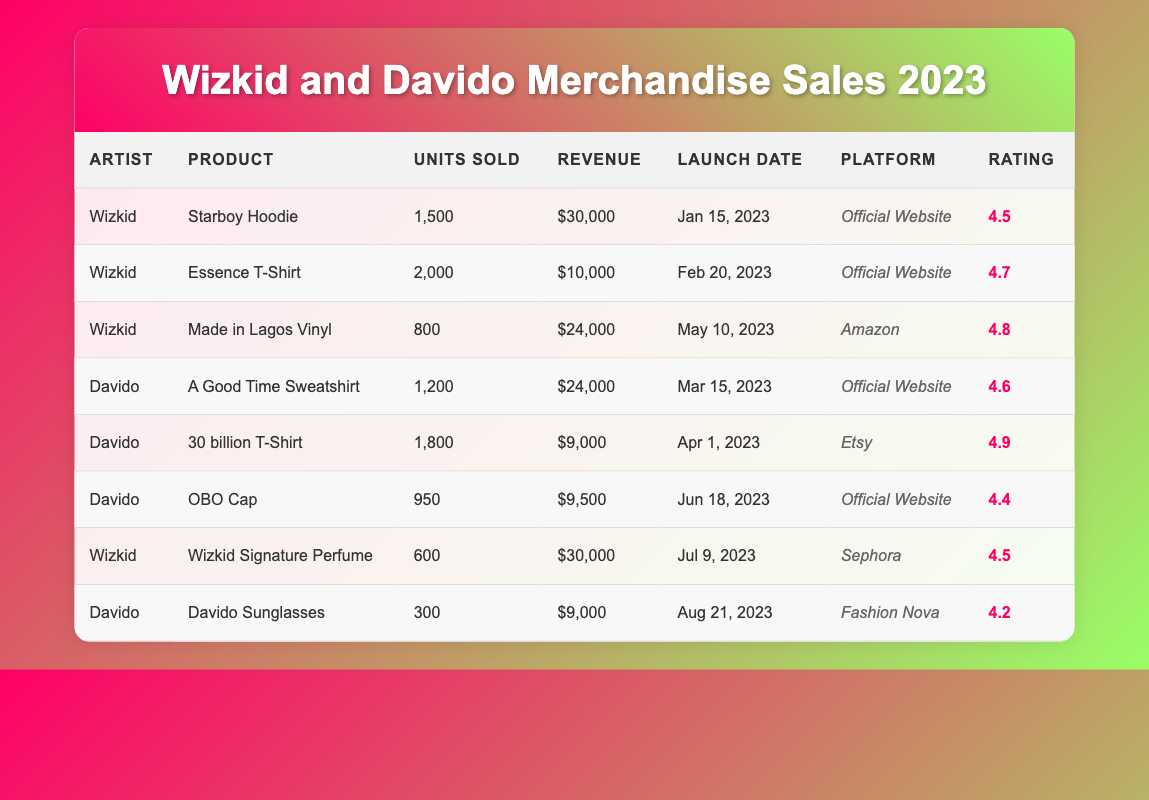What is the total revenue generated by Wizkid's merchandise in 2023? To find the total revenue for Wizkid, we add the revenues from all his products: $30,000 (Starboy Hoodie) + $10,000 (Essence T-Shirt) + $24,000 (Made in Lagos Vinyl) + $30,000 (Wizkid Signature Perfume) = $94,000.
Answer: $94,000 What product of Davido had the highest customer rating? The table shows that the "30 billion T-Shirt" has the highest rating of 4.9 among Davido's products.
Answer: 30 billion T-Shirt How many units of the "Essence T-Shirt" were sold? The units sold for the "Essence T-Shirt" can be directly found in the table, which states it was 2,000 units.
Answer: 2,000 What is the combined total revenue for Davido's merchandise? We need to sum the revenues of Davido's products: $24,000 (A Good Time Sweatshirt) + $9,000 (30 billion T-Shirt) + $9,500 (OBO Cap) + $9,000 (Davido Sunglasses) = $51,500.
Answer: $51,500 Did Wizkid launch the "Made in Lagos Vinyl" before Davido launched any of his products? The "Made in Lagos Vinyl" was launched on May 10, 2023, while Davido's first product, the "A Good Time Sweatshirt," was launched on March 15, 2023. Therefore, it is false that Wizkid's product was launched before Davido's first product.
Answer: No What is the difference in units sold between Wizkid's "Starboy Hoodie" and Davido's "OBO Cap"? To find the difference, we subtract the units sold of the "OBO Cap" (950) from the "Starboy Hoodie" (1,500): 1,500 - 950 = 550.
Answer: 550 Which artist had a product sold on Sephora, and what was the product? The table indicates that the "Wizkid Signature Perfume" is the product sold on Sephora, making Wizkid the artist.
Answer: Wizkid; Wizkid Signature Perfume What is the average customer rating for all Wizkid's products? The ratings for Wizkid's products are: 4.5, 4.7, 4.8, and 4.5. To find the average, we sum them (4.5 + 4.7 + 4.8 + 4.5 = 19.5) and divide by the number of products (4): 19.5 / 4 = 4.875.
Answer: 4.875 Which product generated the highest total revenue? The table shows "Wizkid Signature Perfume" and "Starboy Hoodie" both generated $30,000, making them the highest revenue products.
Answer: Wizkid Signature Perfume and Starboy Hoodie How many more units did Wizkid sell compared to Davido in total? First, we find total units sold for Wizkid: 1,500 + 2,000 + 800 + 600 = 4,900. For Davido: 1,200 + 1,800 + 950 + 300 = 4,250. The difference is 4,900 - 4,250 = 650.
Answer: 650 